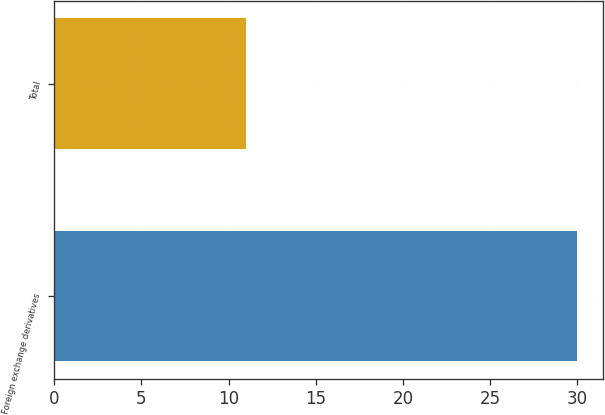Convert chart. <chart><loc_0><loc_0><loc_500><loc_500><bar_chart><fcel>Foreign exchange derivatives<fcel>Total<nl><fcel>30<fcel>11<nl></chart> 